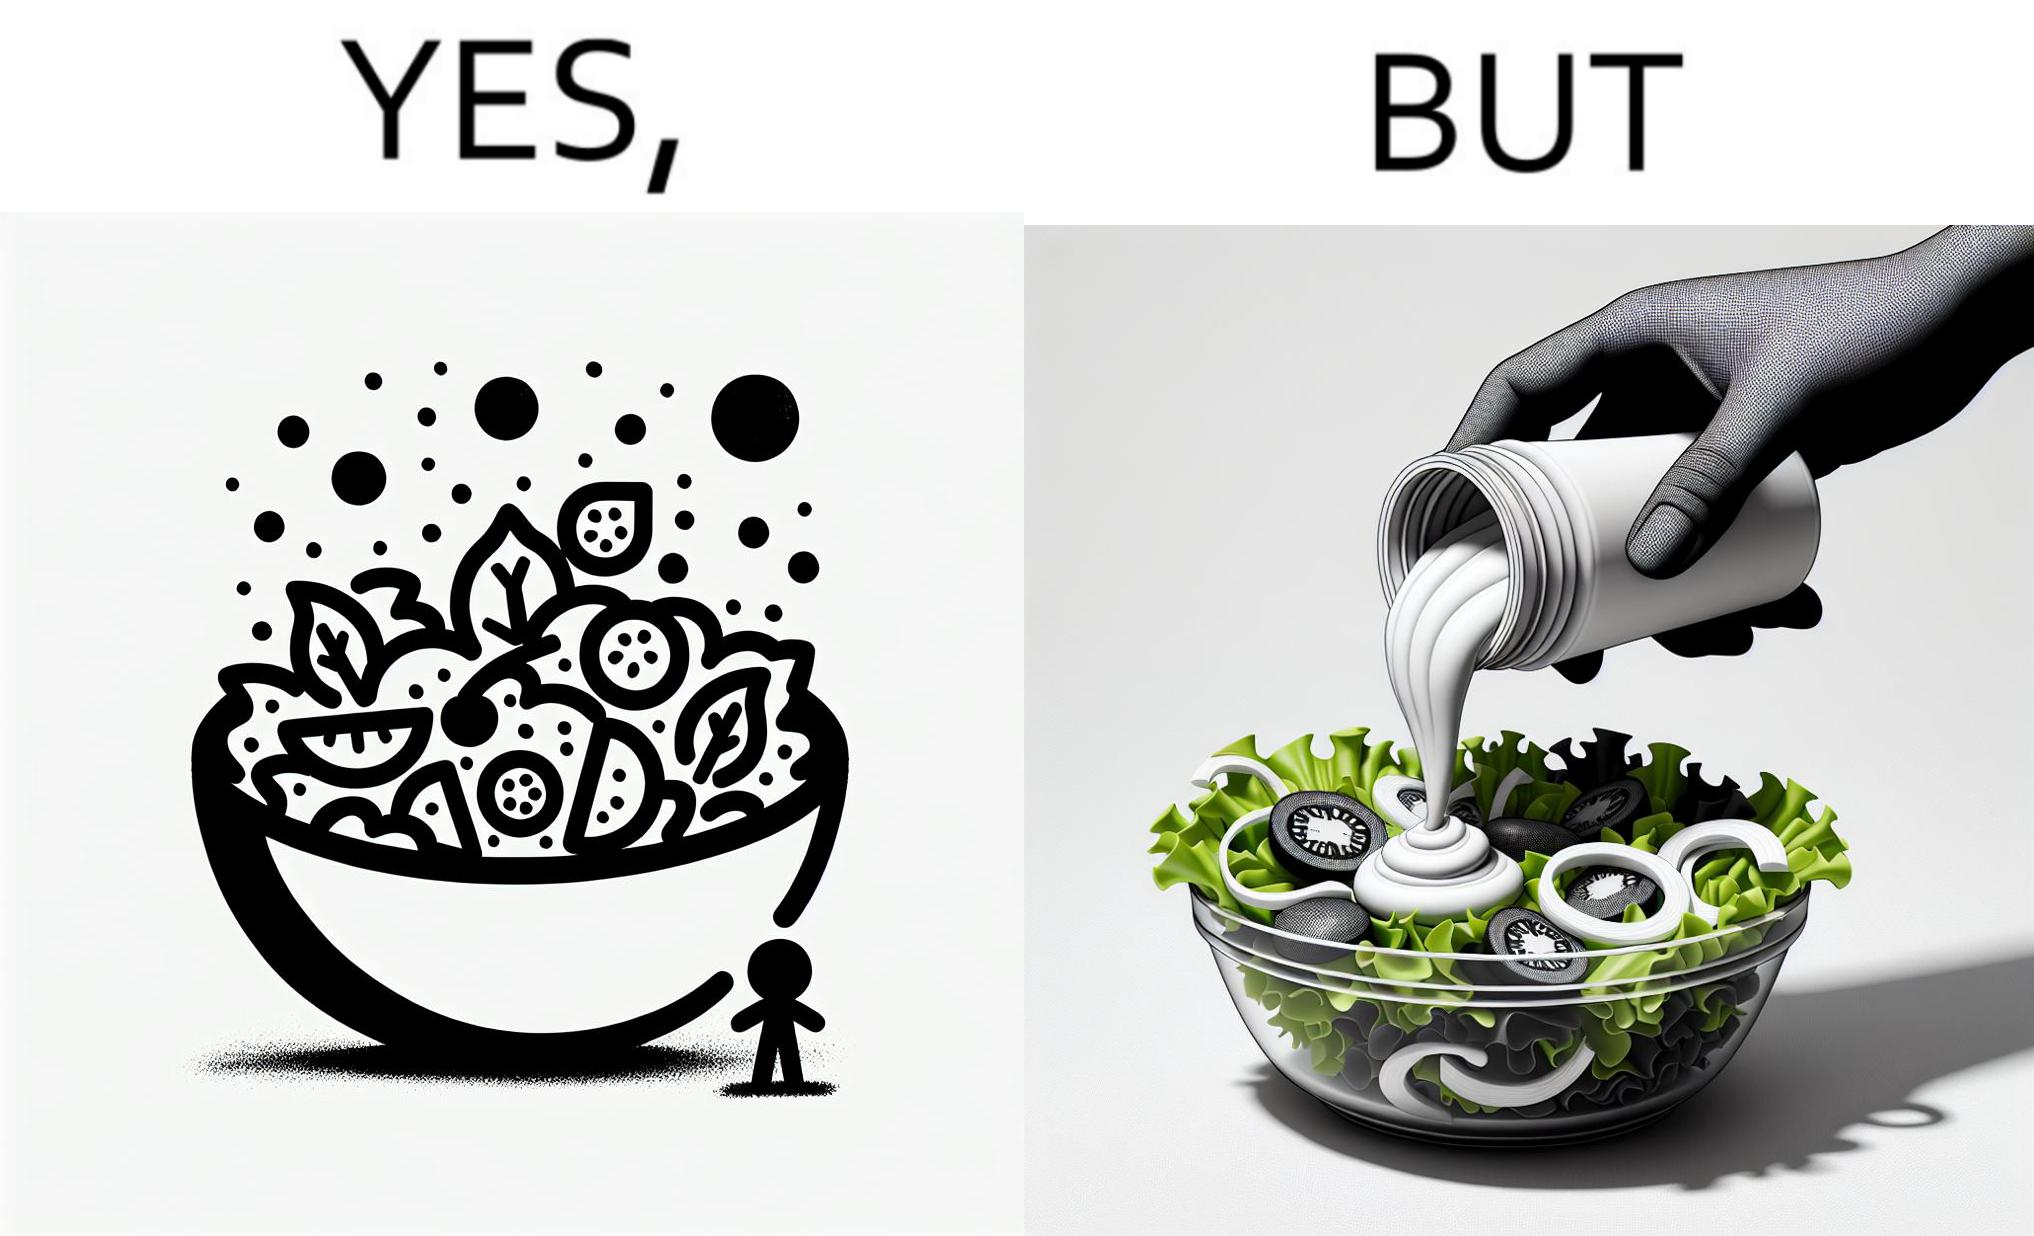Does this image contain satire or humor? Yes, this image is satirical. 